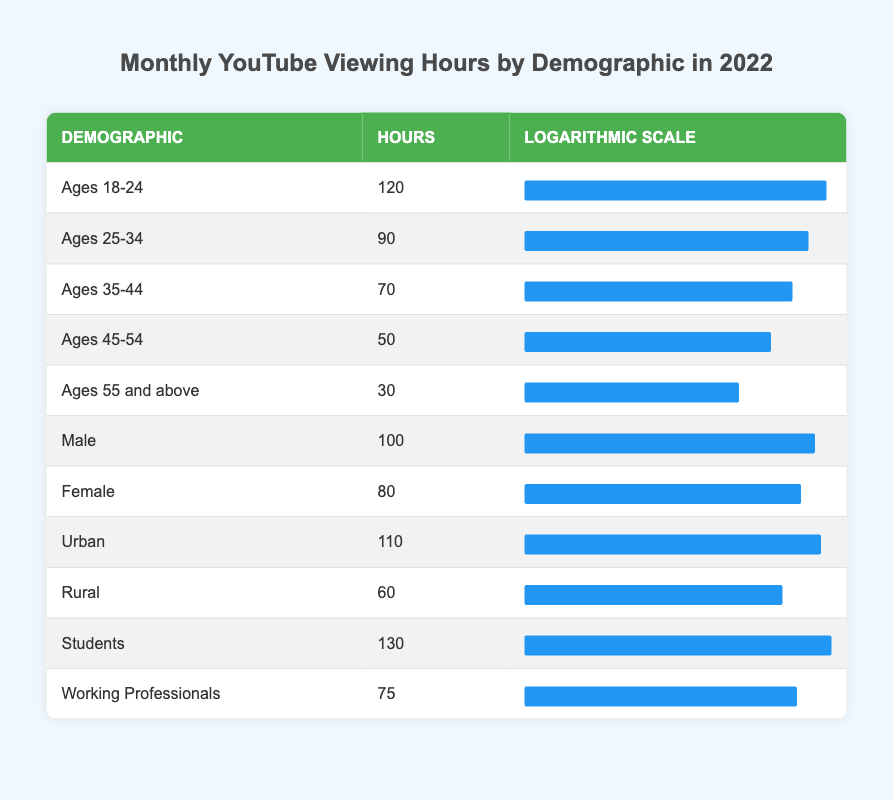What is the highest number of monthly YouTube viewing hours for any demographic? The highest value in the "Hours" column is 130, which corresponds to the "Students" demographic.
Answer: 130 What are the monthly YouTube viewing hours for "Ages 45-54"? Referring to the table, the hours for the "Ages 45-54" demographic is listed as 50.
Answer: 50 Which demographic has the lowest monthly YouTube viewing hours? The demographic with the lowest hours is "Ages 55 and above", with 30 hours recorded in the table.
Answer: Ages 55 and above What is the total monthly YouTube viewing hours for "Male" and "Female" combined? Adding the hours from the two demographics, Male (100) + Female (80) equals 180 total hours.
Answer: 180 Is it true that "Urban" viewing hours are greater than "Rural" viewing hours? Comparing the two, Urban has 110 hours while Rural has 60 hours, confirming that urban viewing hours are greater.
Answer: Yes What is the average monthly YouTube viewing hours for the age groups? The age groups and their hours are 120, 90, 70, 50, and 30. Summing these gives 360 hours, and dividing by 5 groups provides an average of 72 hours.
Answer: 72 How do the viewing hours for "Ages 25-34" compare to "Working Professionals"? "Ages 25-34" has 90 viewing hours, while "Working Professionals" has 75. Since 90 is greater than 75, the younger demographic views more hours.
Answer: Ages 25-34 What is the median viewing hours among all demographics listed? To find the median, the values need to be sorted first: 30, 50, 60, 70, 75, 80, 90, 100, 110, 120, 130; with 11 data points, the median is the 6th value: 80.
Answer: 80 Do "Students" watch less YouTube than those aged 18-24? "Students" have 130 hours compared to "Ages 18-24" who watch 120 hours, so students watch more than this age group.
Answer: No 